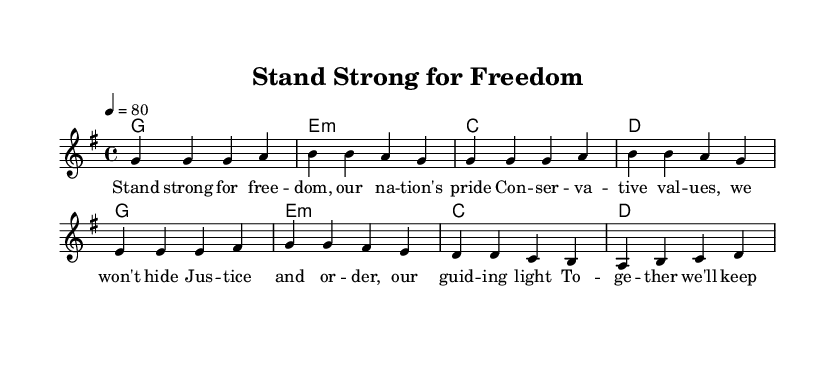What is the key signature of this music? The key signature indicated in the sheet music is G major, which has one sharp (F#).
Answer: G major What is the time signature of this music? The time signature is noted at the beginning of the score with the two numbers stacked, showing that there are four beats in each measure, thus the time signature is 4/4.
Answer: 4/4 What is the tempo marking in the music? The tempo is indicated in the score by "4 = 80," meaning that a quarter note equals 80 beats per minute.
Answer: 80 How many measures are in the melody? Counting the measures in the melody section, there are eight measures provided in the sheet music.
Answer: 8 What is the first note in the melody? Looking at the first note of the melody, it starts on G, as seen in the relative pitch notation of the first measure.
Answer: G What chord follows the first measure? In the chord section, after the first measure, the second measure shows it consists of an E minor chord.
Answer: E minor What theme is expressed through the lyrics of the song? Analyzing the lyrics, the theme revolves around patriotism and conservative values, emphasizing national pride and unity.
Answer: Patriotism 